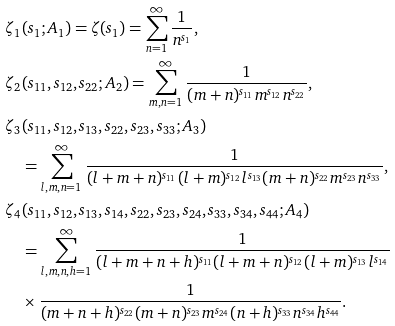Convert formula to latex. <formula><loc_0><loc_0><loc_500><loc_500>& \zeta _ { 1 } ( s _ { 1 } ; A _ { 1 } ) = \zeta ( s _ { 1 } ) = \sum _ { n = 1 } ^ { \infty } \frac { 1 } { n ^ { s _ { 1 } } } , \\ & \zeta _ { 2 } ( s _ { 1 1 } , s _ { 1 2 } , s _ { 2 2 } ; A _ { 2 } ) = \sum _ { m , n = 1 } ^ { \infty } \frac { 1 } { ( m + n ) ^ { s _ { 1 1 } } m ^ { s _ { 1 2 } } n ^ { s _ { 2 2 } } } , \\ & \zeta _ { 3 } ( s _ { 1 1 } , s _ { 1 2 } , s _ { 1 3 } , s _ { 2 2 } , s _ { 2 3 } , s _ { 3 3 } ; A _ { 3 } ) \\ & \quad = \sum _ { l , m , n = 1 } ^ { \infty } \frac { 1 } { ( l + m + n ) ^ { s _ { 1 1 } } ( l + m ) ^ { s _ { 1 2 } } l ^ { s _ { 1 3 } } ( m + n ) ^ { s _ { 2 2 } } m ^ { s _ { 2 3 } } n ^ { s _ { 3 3 } } } , \\ & \zeta _ { 4 } ( s _ { 1 1 } , s _ { 1 2 } , s _ { 1 3 } , s _ { 1 4 } , s _ { 2 2 } , s _ { 2 3 } , s _ { 2 4 } , s _ { 3 3 } , s _ { 3 4 } , s _ { 4 4 } ; A _ { 4 } ) \\ & \quad = \sum _ { l , m , n , h = 1 } ^ { \infty } \frac { 1 } { ( l + m + n + h ) ^ { s _ { 1 1 } } ( l + m + n ) ^ { s _ { 1 2 } } ( l + m ) ^ { s _ { 1 3 } } l ^ { s _ { 1 4 } } } \\ & \quad \times \frac { 1 } { ( m + n + h ) ^ { s _ { 2 2 } } ( m + n ) ^ { s _ { 2 3 } } m ^ { s _ { 2 4 } } ( n + h ) ^ { s _ { 3 3 } } n ^ { s _ { 3 4 } } h ^ { s _ { 4 4 } } } .</formula> 